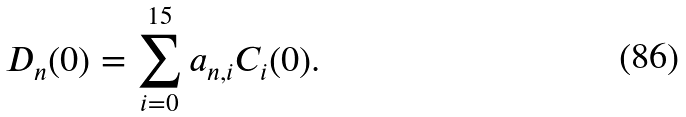<formula> <loc_0><loc_0><loc_500><loc_500>D _ { n } ( 0 ) = \sum _ { i = 0 } ^ { 1 5 } a _ { n , i } C _ { i } ( 0 ) .</formula> 